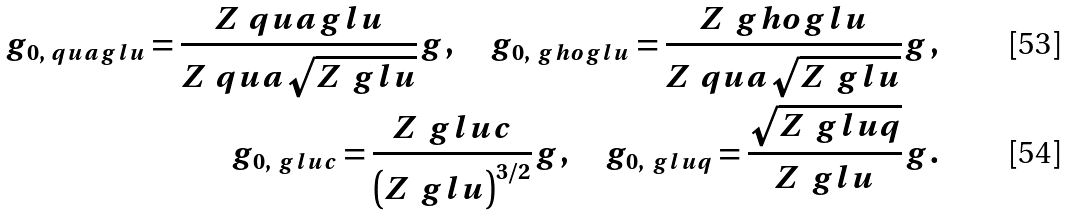Convert formula to latex. <formula><loc_0><loc_0><loc_500><loc_500>g _ { 0 , \ q u a g l u } = \frac { Z ^ { \ } q u a g l u } { Z ^ { \ } q u a \sqrt { Z ^ { \ } g l u } } g , \quad g _ { 0 , \ g h o g l u } = \frac { Z ^ { \ } g h o g l u } { Z ^ { \ } q u a \sqrt { Z ^ { \ } g l u } } g , \\ g _ { 0 , \ g l u c } = \frac { Z ^ { \ } g l u c } { \left ( Z ^ { \ } g l u \right ) ^ { 3 / 2 } } g , \quad g _ { 0 , \ g l u q } = \frac { \sqrt { Z ^ { \ } g l u q } } { Z ^ { \ } g l u } g .</formula> 